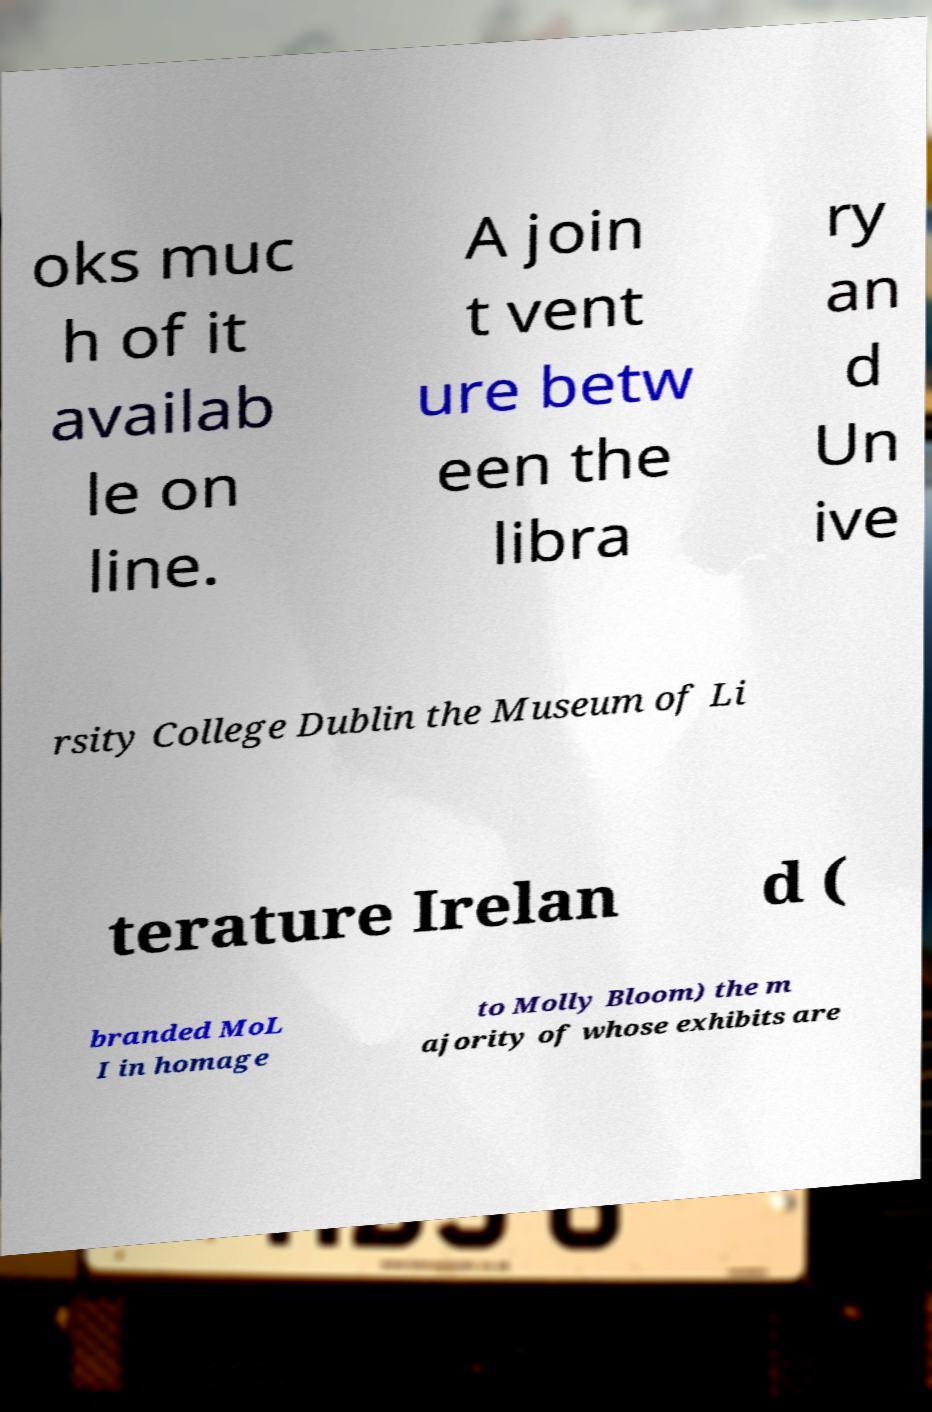There's text embedded in this image that I need extracted. Can you transcribe it verbatim? oks muc h of it availab le on line. A join t vent ure betw een the libra ry an d Un ive rsity College Dublin the Museum of Li terature Irelan d ( branded MoL I in homage to Molly Bloom) the m ajority of whose exhibits are 